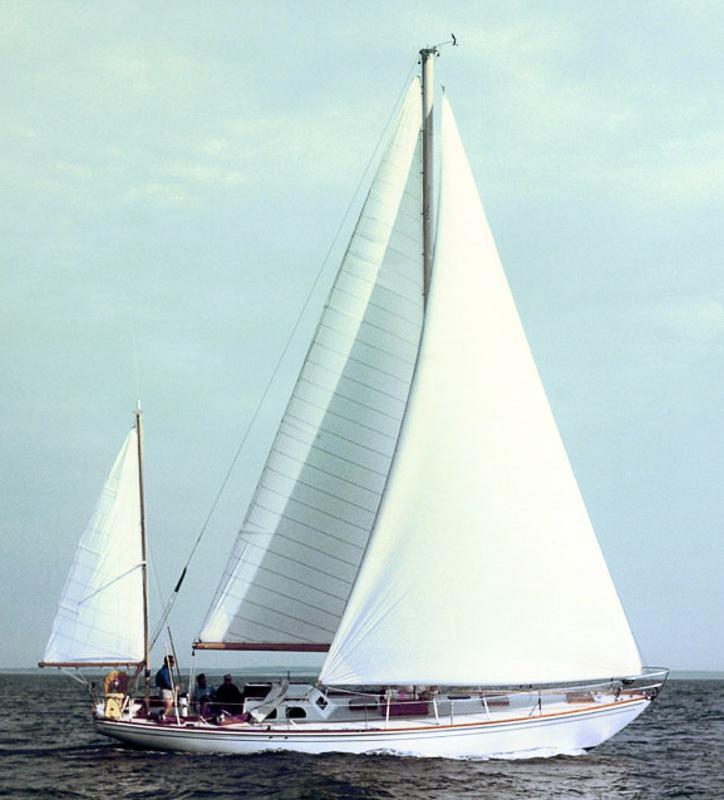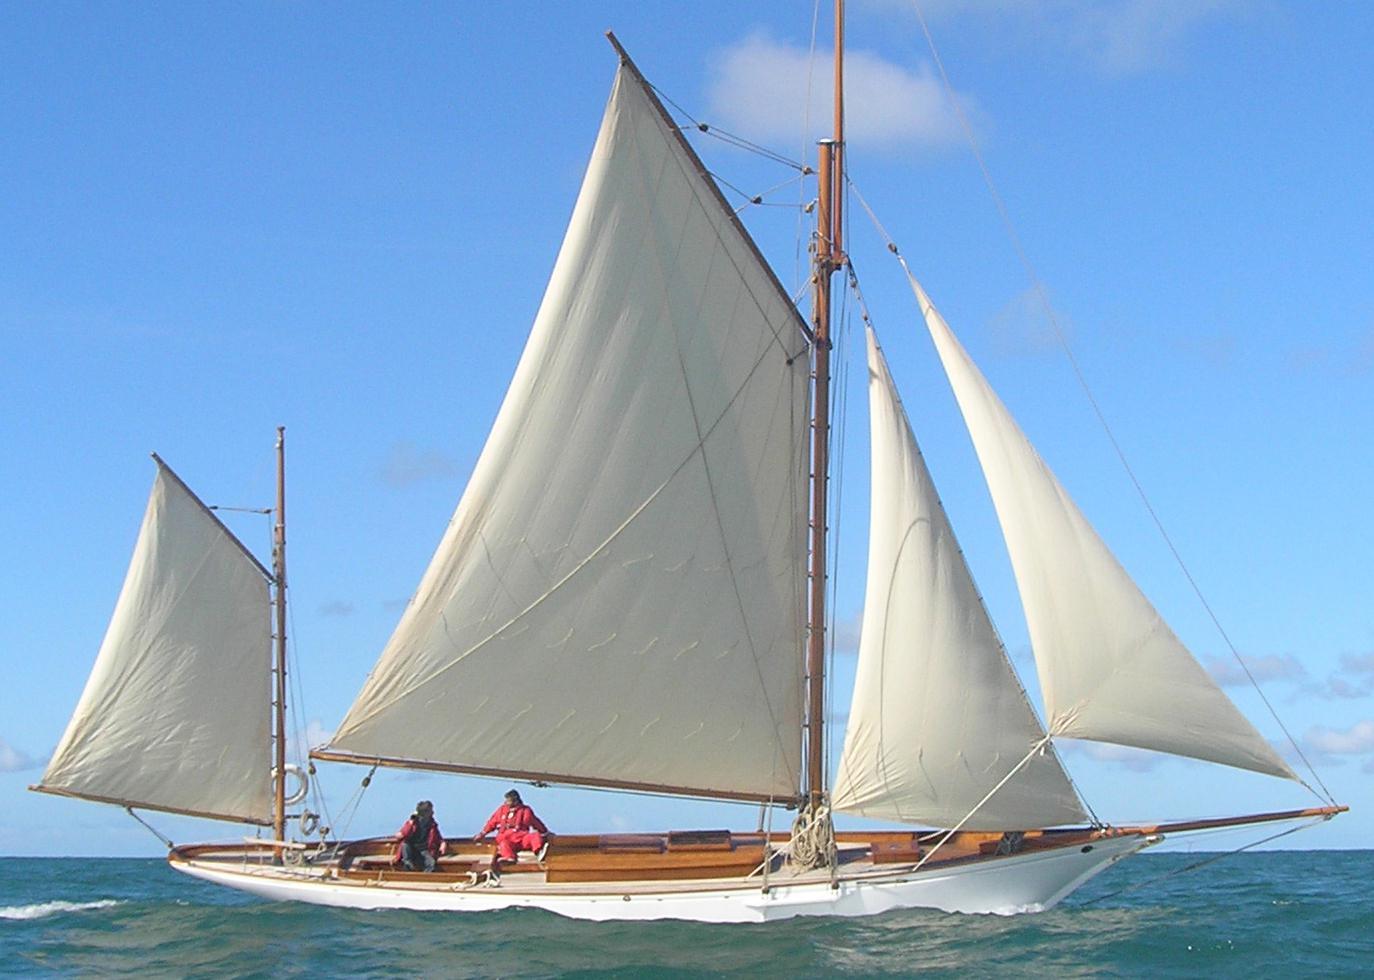The first image is the image on the left, the second image is the image on the right. For the images displayed, is the sentence "There is a person in a red coat in one of the images" factually correct? Answer yes or no. Yes. 